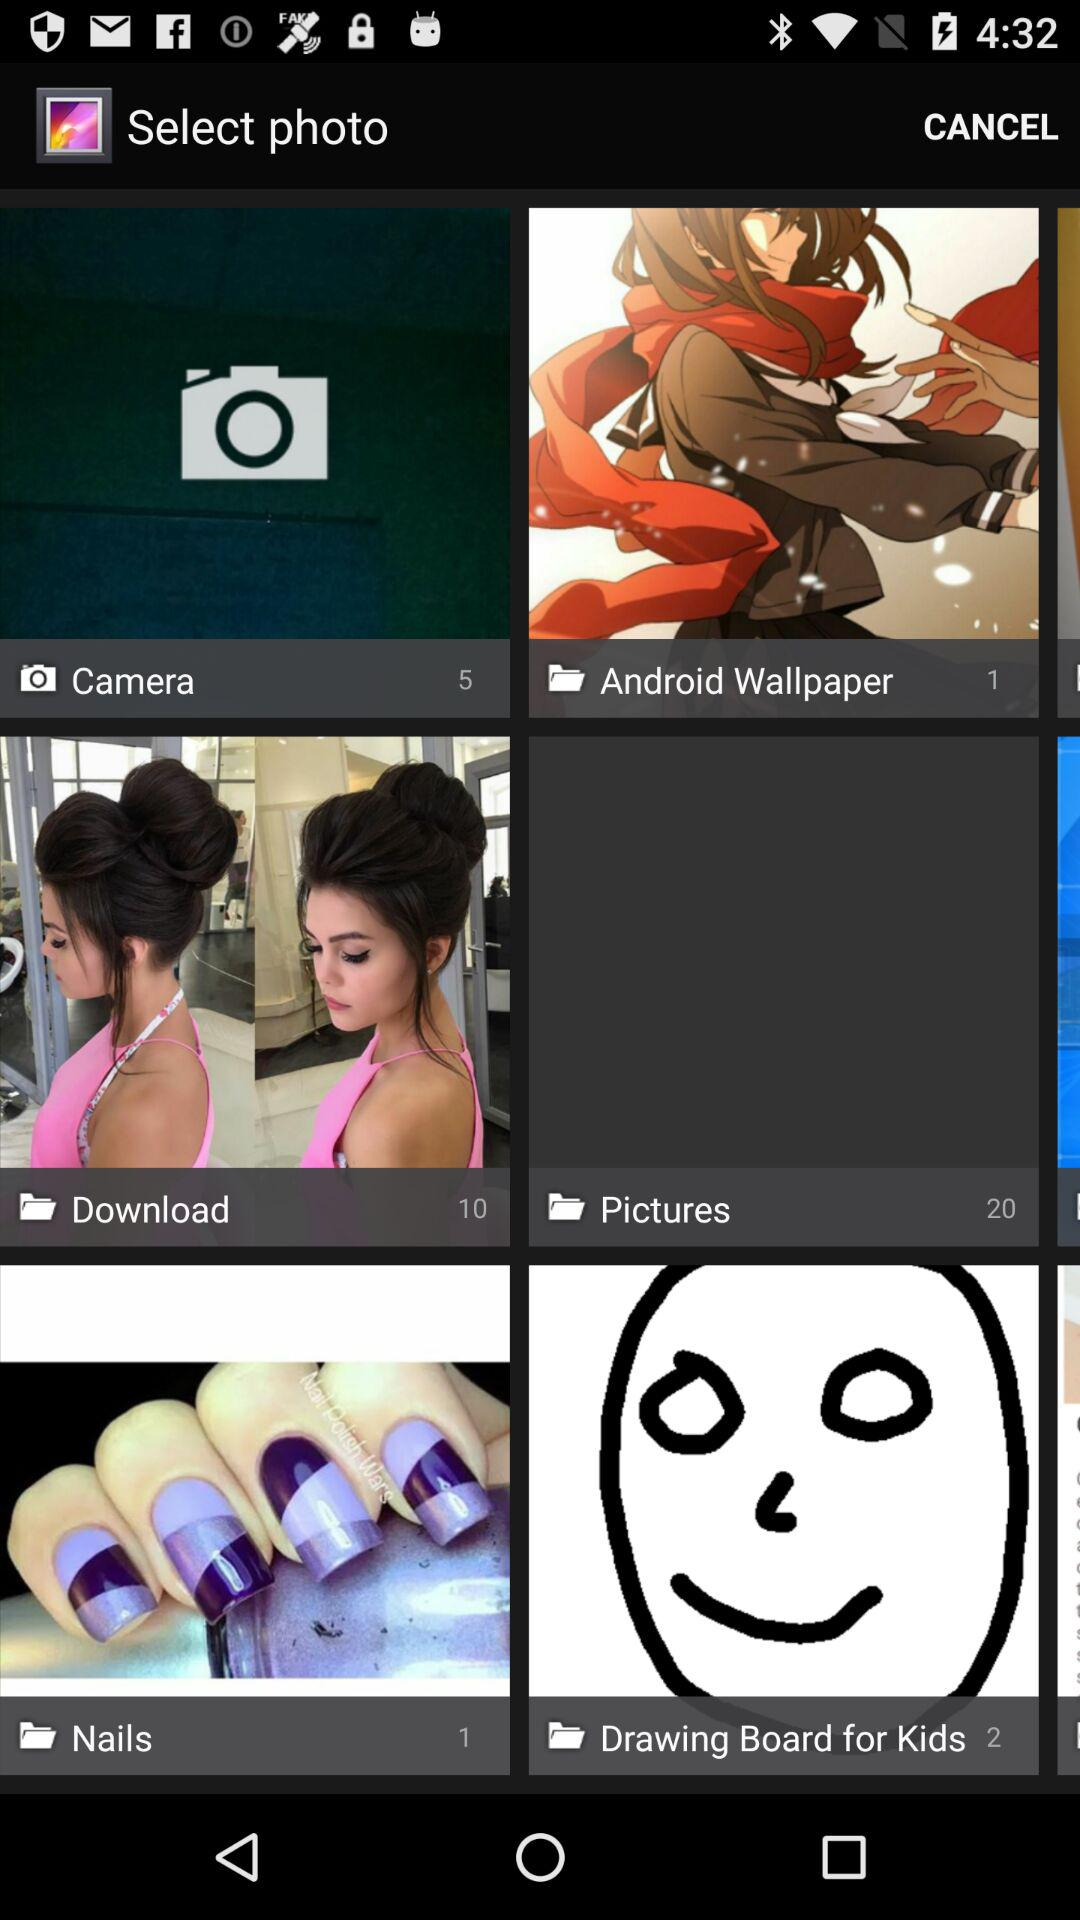How many photos are there in "Pictures"? There are 20 photos in "Pictures". 